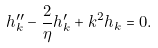<formula> <loc_0><loc_0><loc_500><loc_500>h _ { k } ^ { \prime \prime } - \frac { 2 } { \eta } h _ { k } ^ { \prime } + k ^ { 2 } h _ { k } = 0 .</formula> 